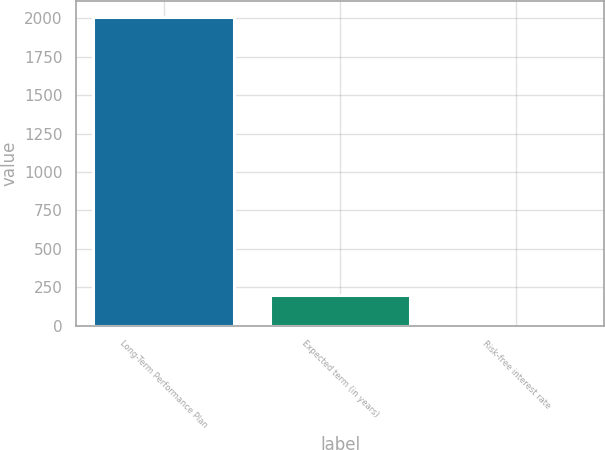<chart> <loc_0><loc_0><loc_500><loc_500><bar_chart><fcel>Long-Term Performance Plan<fcel>Expected term (in years)<fcel>Risk-free interest rate<nl><fcel>2009<fcel>201.44<fcel>0.6<nl></chart> 